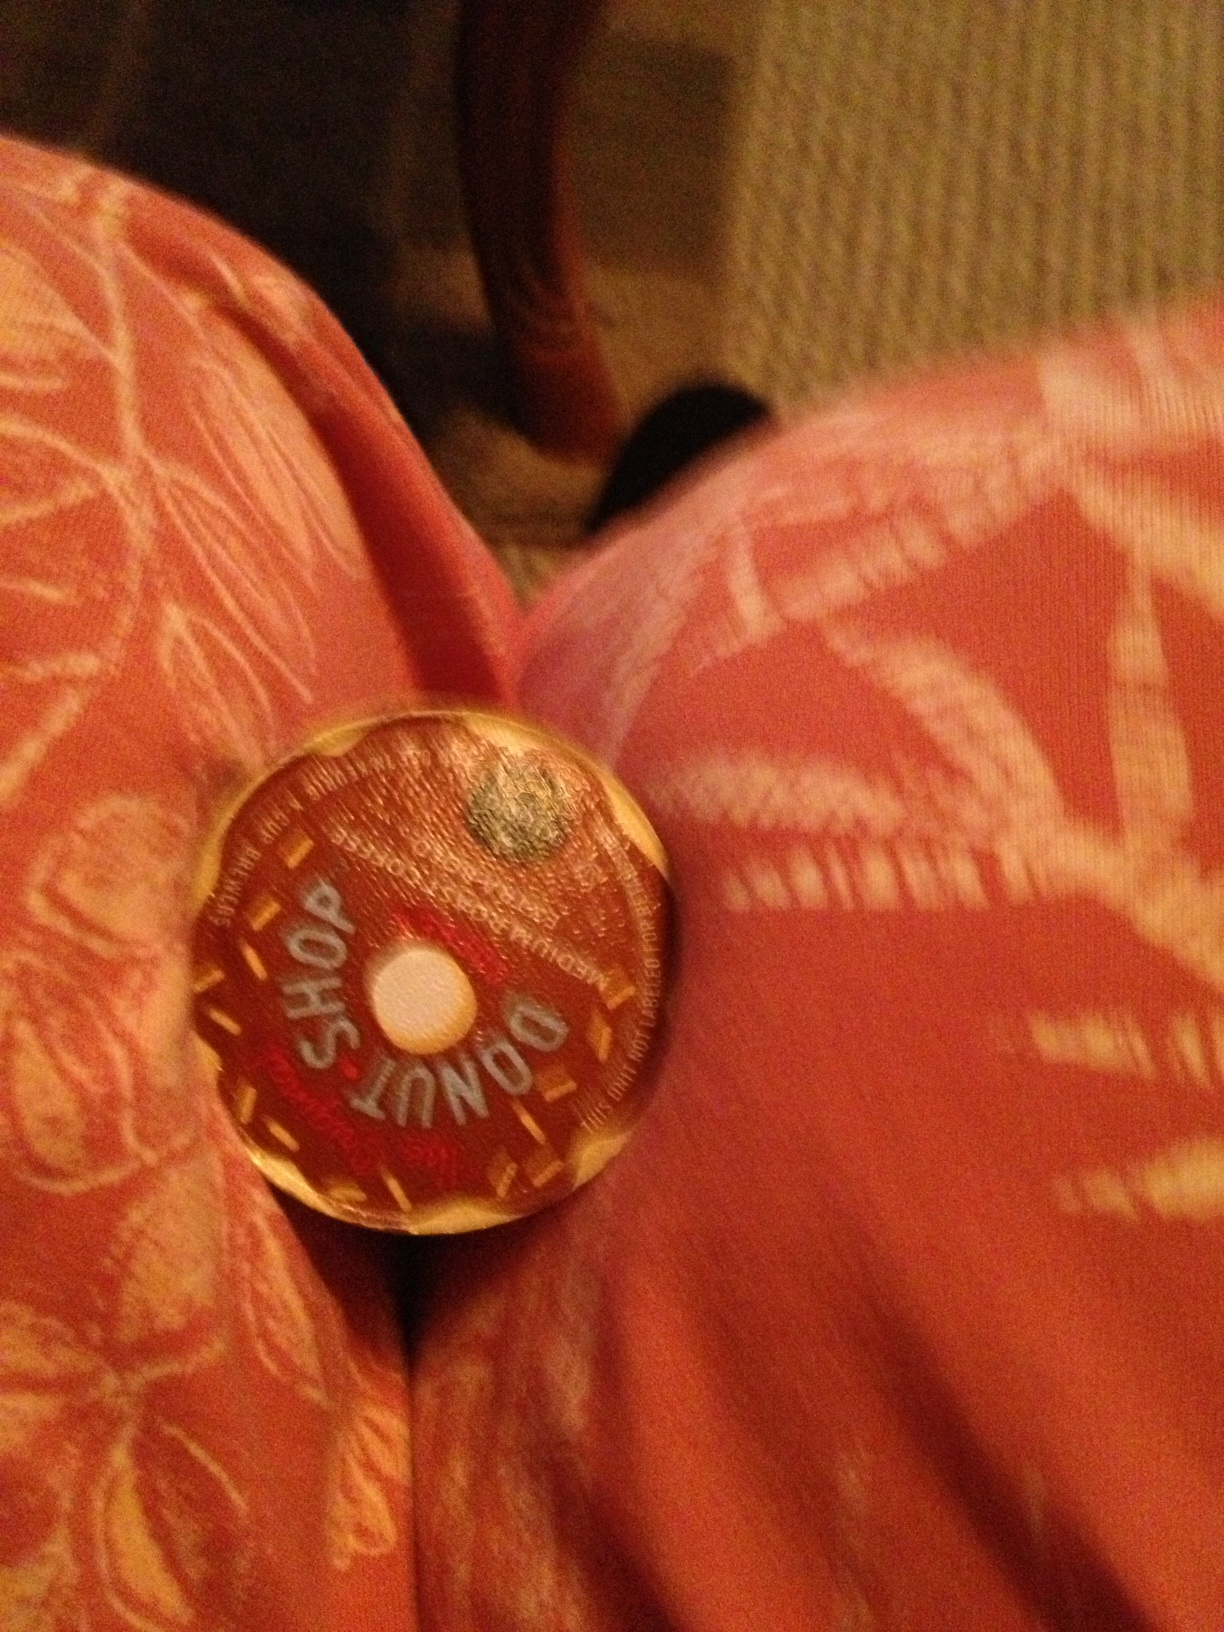Imagine a busy workday scenario. How would a cup of Donut Shop coffee help you get through it? On a busy workday, a cup of Donut Shop coffee provides a delightful moment of respite. As deadlines loom and emails flood in, you take a brief pause to enjoy the rich, comforting flavor of your coffee. The familiarity of its taste brings a sense of calm and focus, helping you to rejuvenate and tackle your tasks with a refreshed mind. 